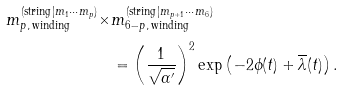Convert formula to latex. <formula><loc_0><loc_0><loc_500><loc_500>m ^ { ( \text {string} | m _ { 1 } \cdots m _ { p } ) } _ { p , \, \text {winding} } \times & m ^ { ( \text {string} | m _ { p + 1 } \cdots m _ { 6 } ) } _ { 6 - p , \, \text {winding} } \\ & = \left ( \frac { 1 } { \sqrt { \alpha ^ { \prime } } } \right ) ^ { 2 } \exp \left ( - 2 \phi ( t ) + \overline { \lambda } ( t ) \right ) .</formula> 